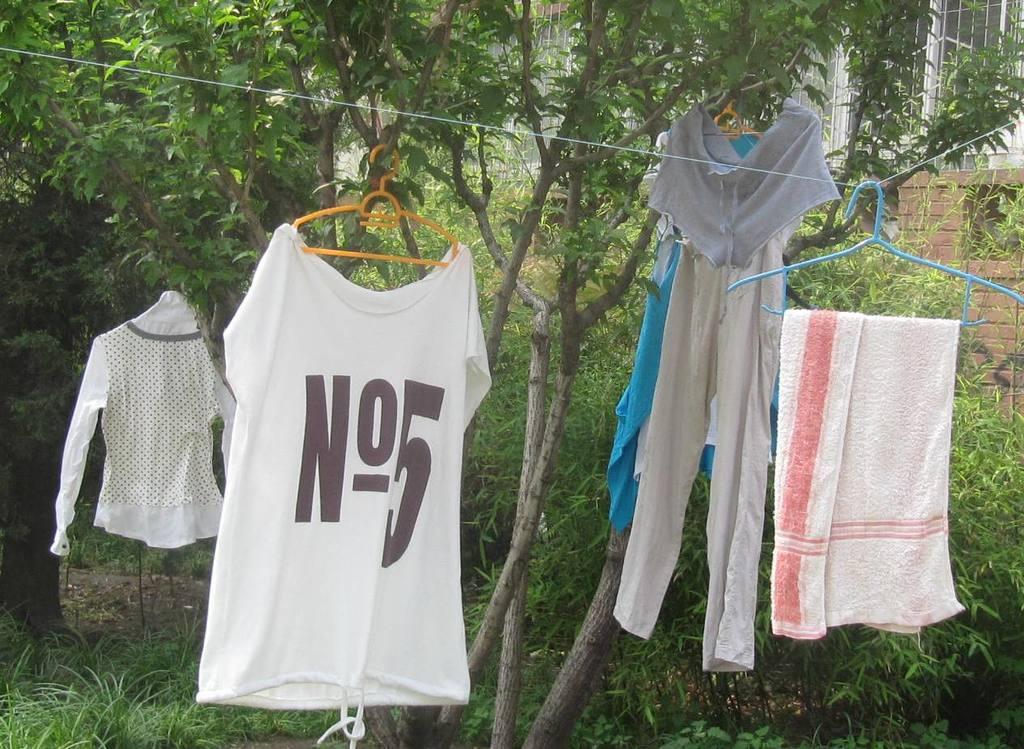What's the number?
Offer a very short reply. 5. What letter is written on the shirt?
Offer a very short reply. N. 